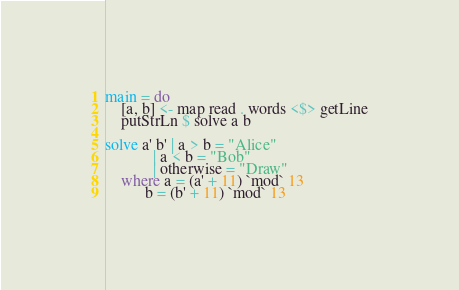<code> <loc_0><loc_0><loc_500><loc_500><_Haskell_>main = do
    [a, b] <- map read . words <$> getLine
    putStrLn $ solve a b

solve a' b' | a > b = "Alice"
            | a < b = "Bob"
            | otherwise = "Draw"
    where a = (a' + 11) `mod` 13
          b = (b' + 11) `mod` 13</code> 